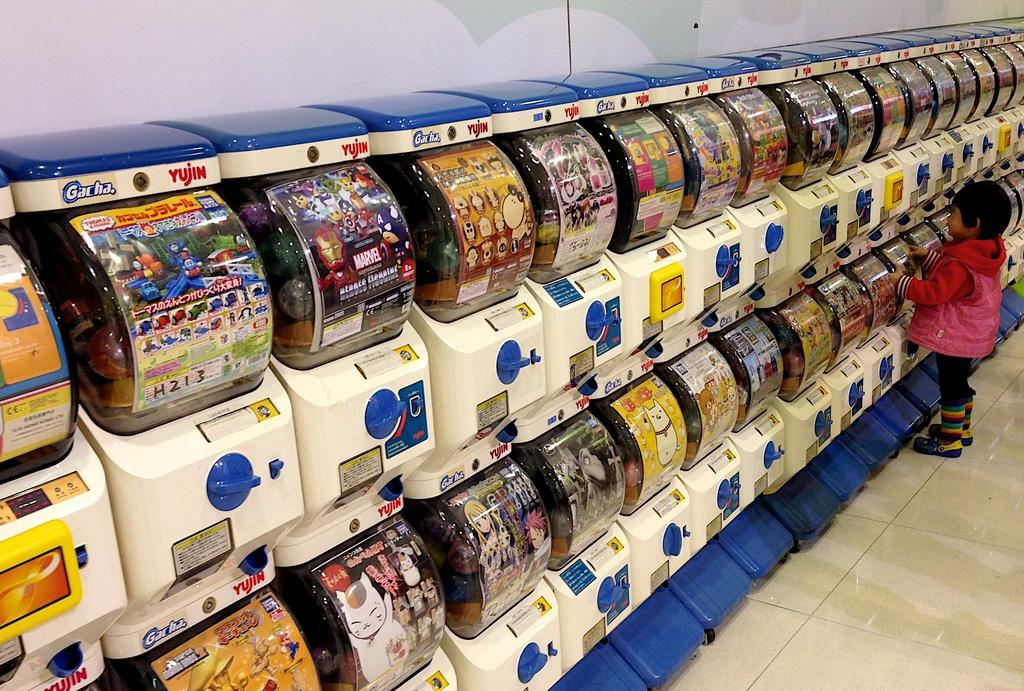<image>
Provide a brief description of the given image. A young girl looks at candy in Gacha Yujin display containers. 